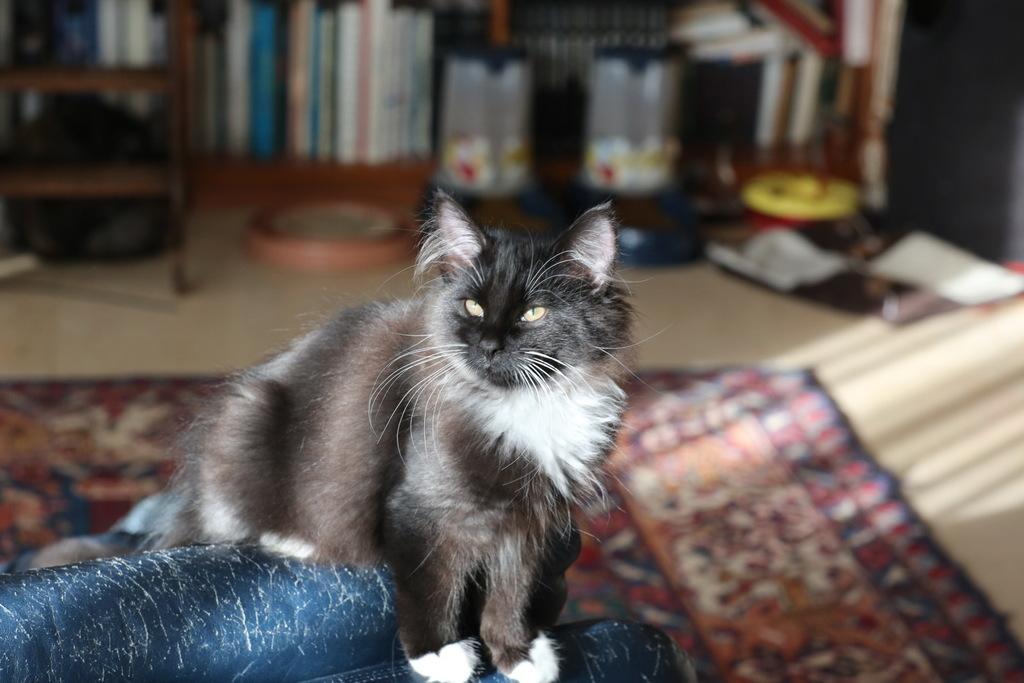Please provide a concise description of this image. In this image we can see a cat on the surface. In the background, we can see some books and some objects placed on the surface. On the left side of the image we can see a ladder. 